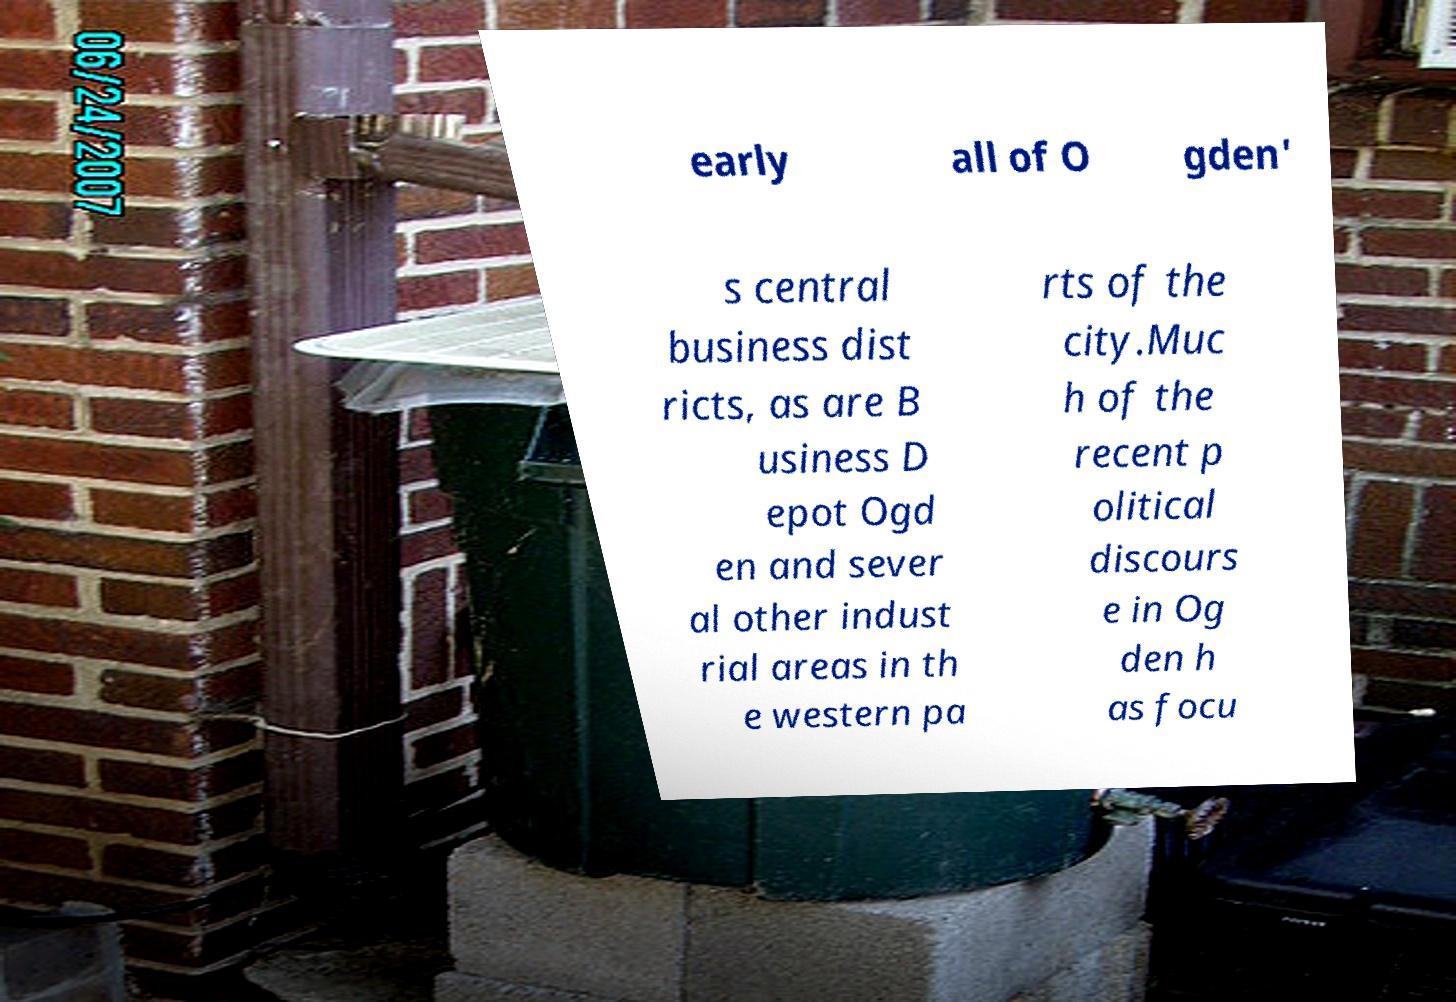Please identify and transcribe the text found in this image. early all of O gden' s central business dist ricts, as are B usiness D epot Ogd en and sever al other indust rial areas in th e western pa rts of the city.Muc h of the recent p olitical discours e in Og den h as focu 